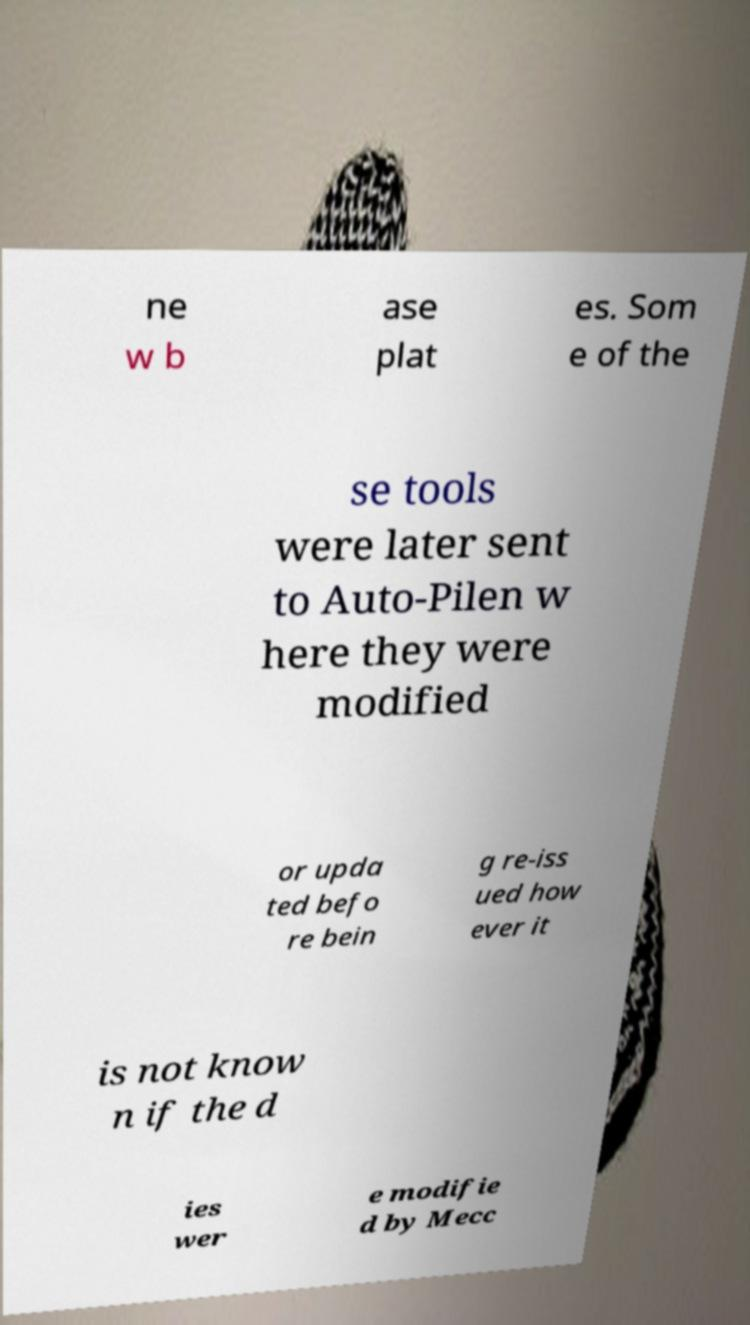I need the written content from this picture converted into text. Can you do that? ne w b ase plat es. Som e of the se tools were later sent to Auto-Pilen w here they were modified or upda ted befo re bein g re-iss ued how ever it is not know n if the d ies wer e modifie d by Mecc 